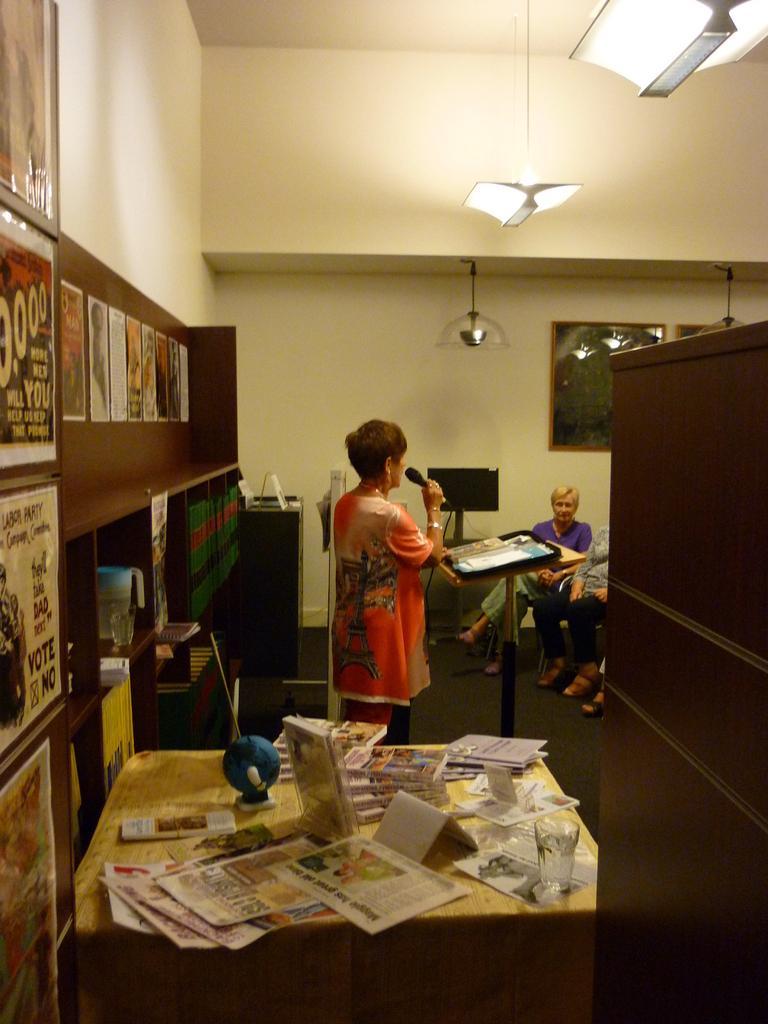How would you summarize this image in a sentence or two? In this picture there is a woman standing and looking at the persons sitting in front of her. On to the right there is a table with some papers on it. In the backdrop there is a wooden wall with some posters pasted on it. 